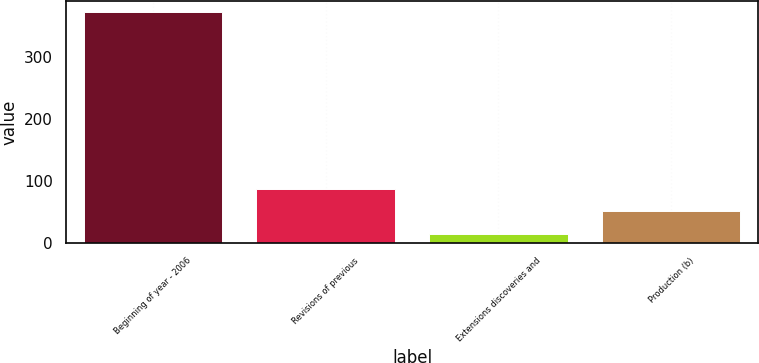<chart> <loc_0><loc_0><loc_500><loc_500><bar_chart><fcel>Beginning of year - 2006<fcel>Revisions of previous<fcel>Extensions discoveries and<fcel>Production (b)<nl><fcel>373<fcel>86.6<fcel>15<fcel>50.8<nl></chart> 